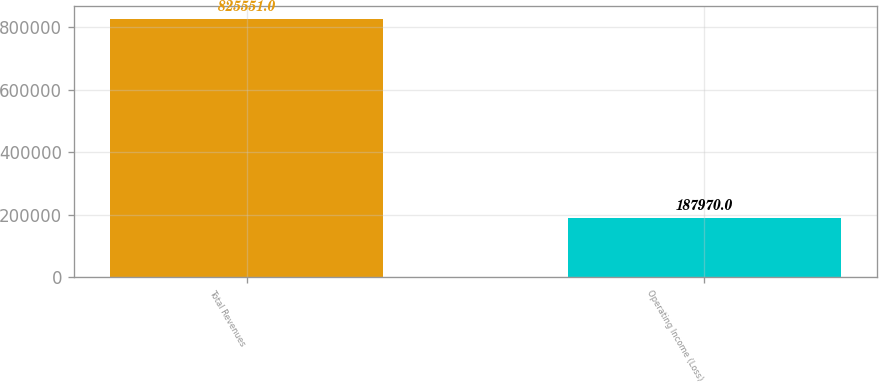Convert chart to OTSL. <chart><loc_0><loc_0><loc_500><loc_500><bar_chart><fcel>Total Revenues<fcel>Operating Income (Loss)<nl><fcel>825551<fcel>187970<nl></chart> 